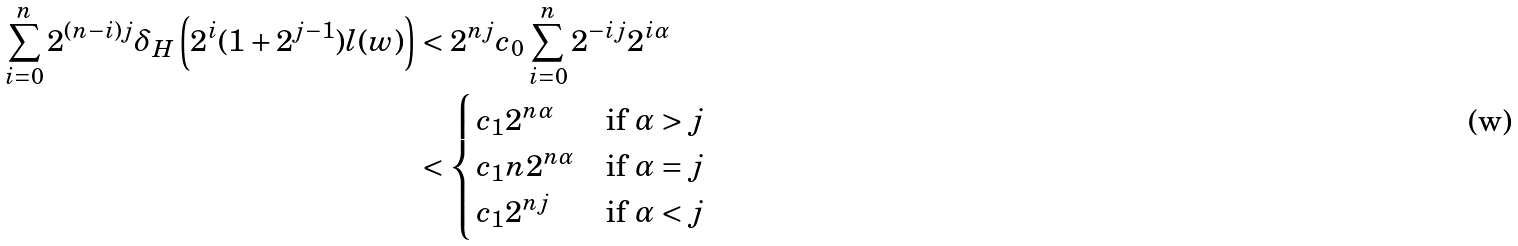<formula> <loc_0><loc_0><loc_500><loc_500>\sum _ { i = 0 } ^ { n } 2 ^ { ( n - i ) j } \delta _ { H } \left ( 2 ^ { i } ( 1 + 2 ^ { j - 1 } ) l ( w ) \right ) & < 2 ^ { n j } c _ { 0 } \sum _ { i = 0 } ^ { n } 2 ^ { - i j } 2 ^ { i \alpha } \\ & < \begin{cases} c _ { 1 } 2 ^ { n \alpha } & \text {if $\alpha>j$} \\ c _ { 1 } n 2 ^ { n \alpha } & \text {if $\alpha=j$} \\ c _ { 1 } 2 ^ { n j } & \text {if $\alpha<j$} \end{cases}</formula> 